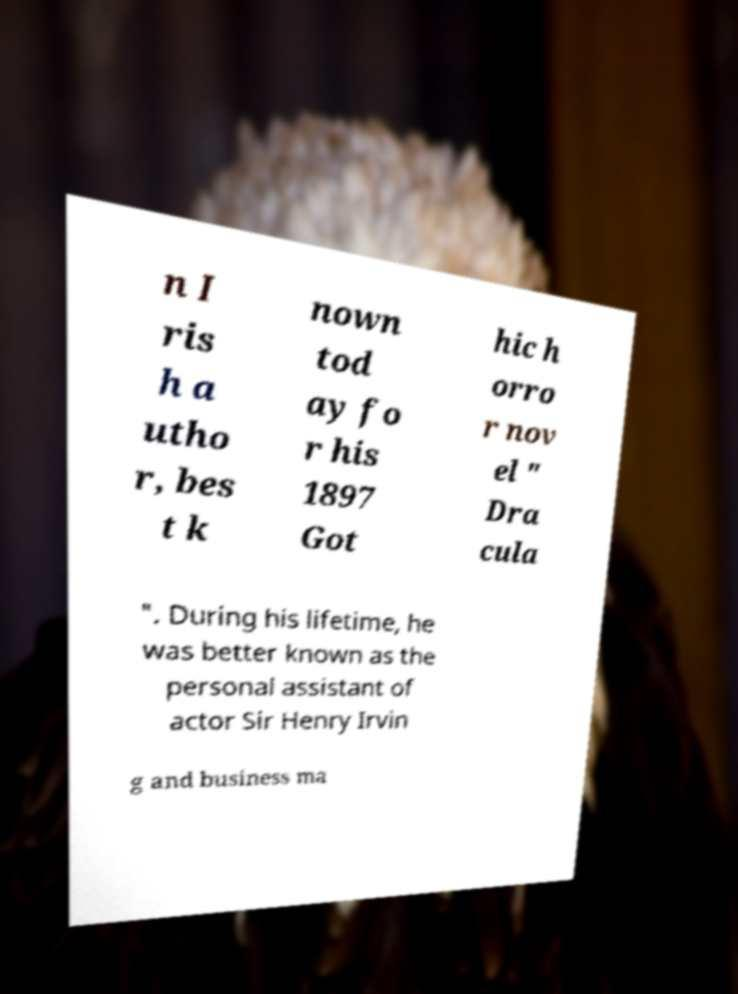Can you accurately transcribe the text from the provided image for me? n I ris h a utho r, bes t k nown tod ay fo r his 1897 Got hic h orro r nov el " Dra cula ". During his lifetime, he was better known as the personal assistant of actor Sir Henry Irvin g and business ma 